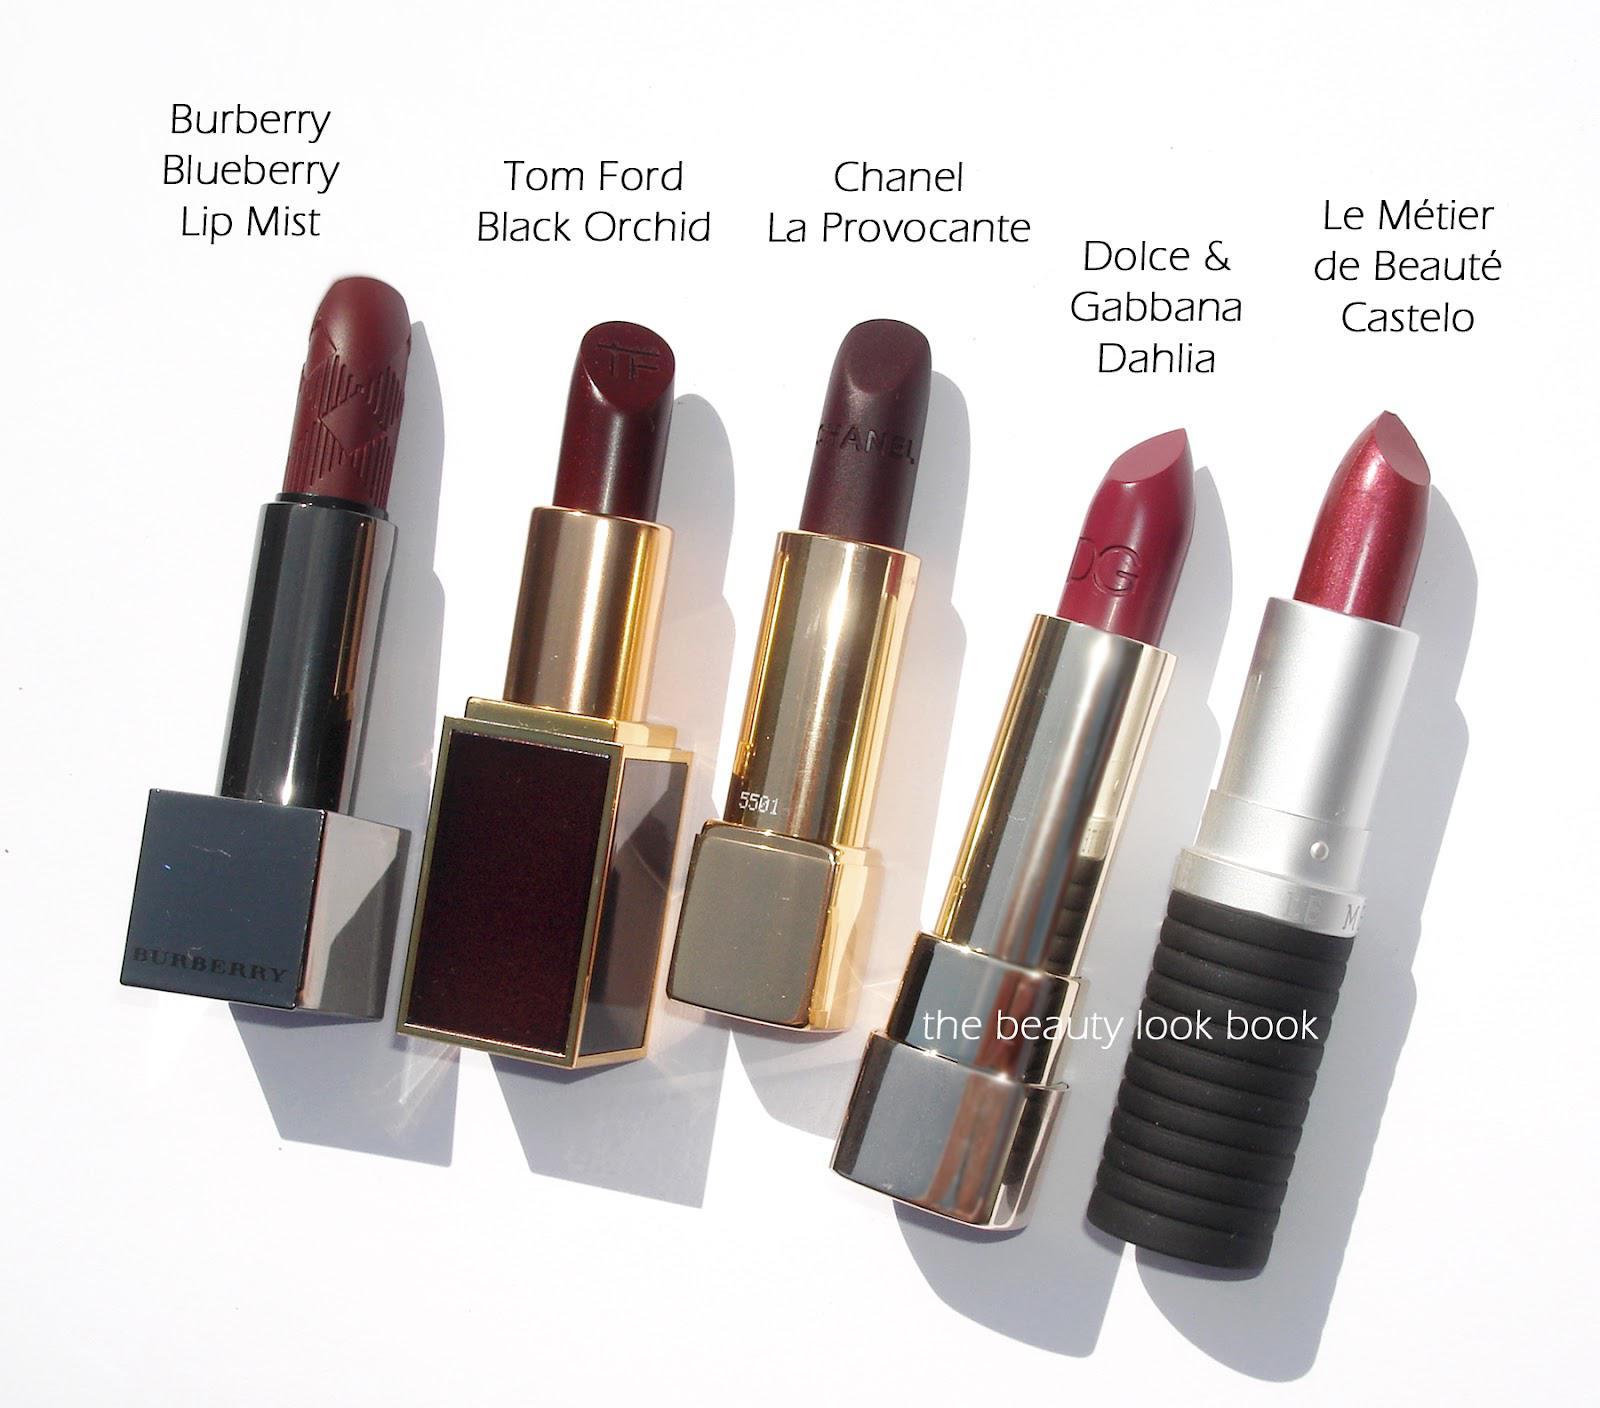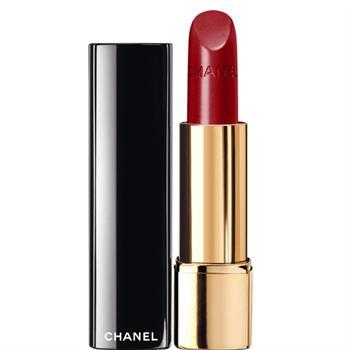The first image is the image on the left, the second image is the image on the right. Considering the images on both sides, is "One image shows a single red upright lipstick next to its upright cover." valid? Answer yes or no. Yes. The first image is the image on the left, the second image is the image on the right. Considering the images on both sides, is "One images shows at least five tubes of lipstick with all the caps off lined up in a row." valid? Answer yes or no. Yes. 